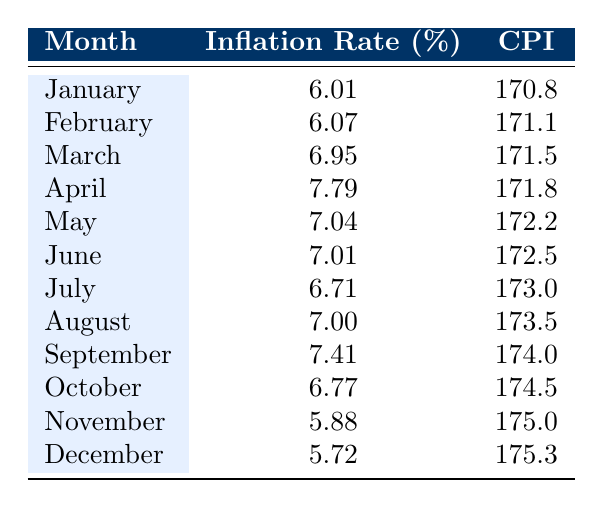What was the highest inflation rate in India in 2022? By evaluating the Inflation Rate column, I find that the maximum value is 7.79 in April.
Answer: 7.79 What month had the lowest inflation rate in 2022? Looking at the Inflation Rate values, I can see that November has the lowest rate of 5.88.
Answer: November What was the inflation rate in September and how does it compare to October? The inflation rate for September is 7.41 while October's rate is 6.77. Hence, September has a higher rate by 0.64.
Answer: September is higher by 0.64 What is the average inflation rate for the first quarter (January to March) of 2022? The values for January, February, and March are 6.01, 6.07, and 6.95 respectively. Summing these gives 18.03, dividing by 3 results in an average of 6.01.
Answer: 6.01 Did the inflation rate decrease in December compared to November? December's inflation rate is 5.72 and November's is 5.88. Since 5.72 is less than 5.88, the inflation rate did decrease.
Answer: Yes Which month saw an inflation rate of exactly 7.00%? Examining the table, I see that August has an inflation rate of precisely 7.00%.
Answer: August What was the percentage increase from the lowest inflation rate to the highest inflation rate during the year? The lowest inflation rate is 5.72 (December) and the highest is 7.79 (April). The increase is 7.79 - 5.72 = 2.07. The percentage increase is (2.07 / 5.72) * 100 = 36.26%.
Answer: 36.26% How many months had an inflation rate of 6.5% or higher? Counting the months where the inflation rate is 6.5% or greater, I find there's January, February, March, April, May, June, July, August, September, and October; this totals 10 months.
Answer: 10 What was the trend of the inflation rates from January to December? Observing the rates month by month, they start at 6.01 in January, peak to 7.79 in April, then show a gradual decline but with fluctuations, ending at 5.72 in December indicating a general downward trend after April.
Answer: General downward trend after April 